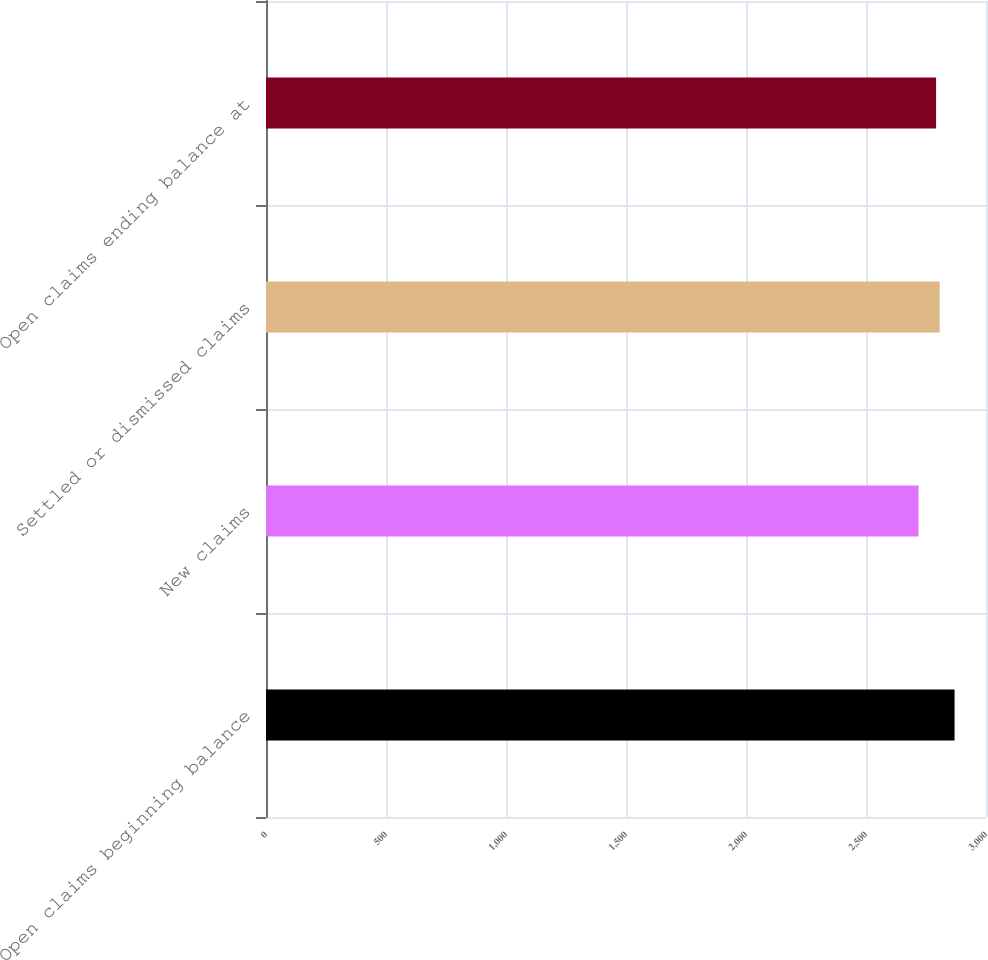Convert chart. <chart><loc_0><loc_0><loc_500><loc_500><bar_chart><fcel>Open claims beginning balance<fcel>New claims<fcel>Settled or dismissed claims<fcel>Open claims ending balance at<nl><fcel>2869<fcel>2719<fcel>2807<fcel>2792<nl></chart> 